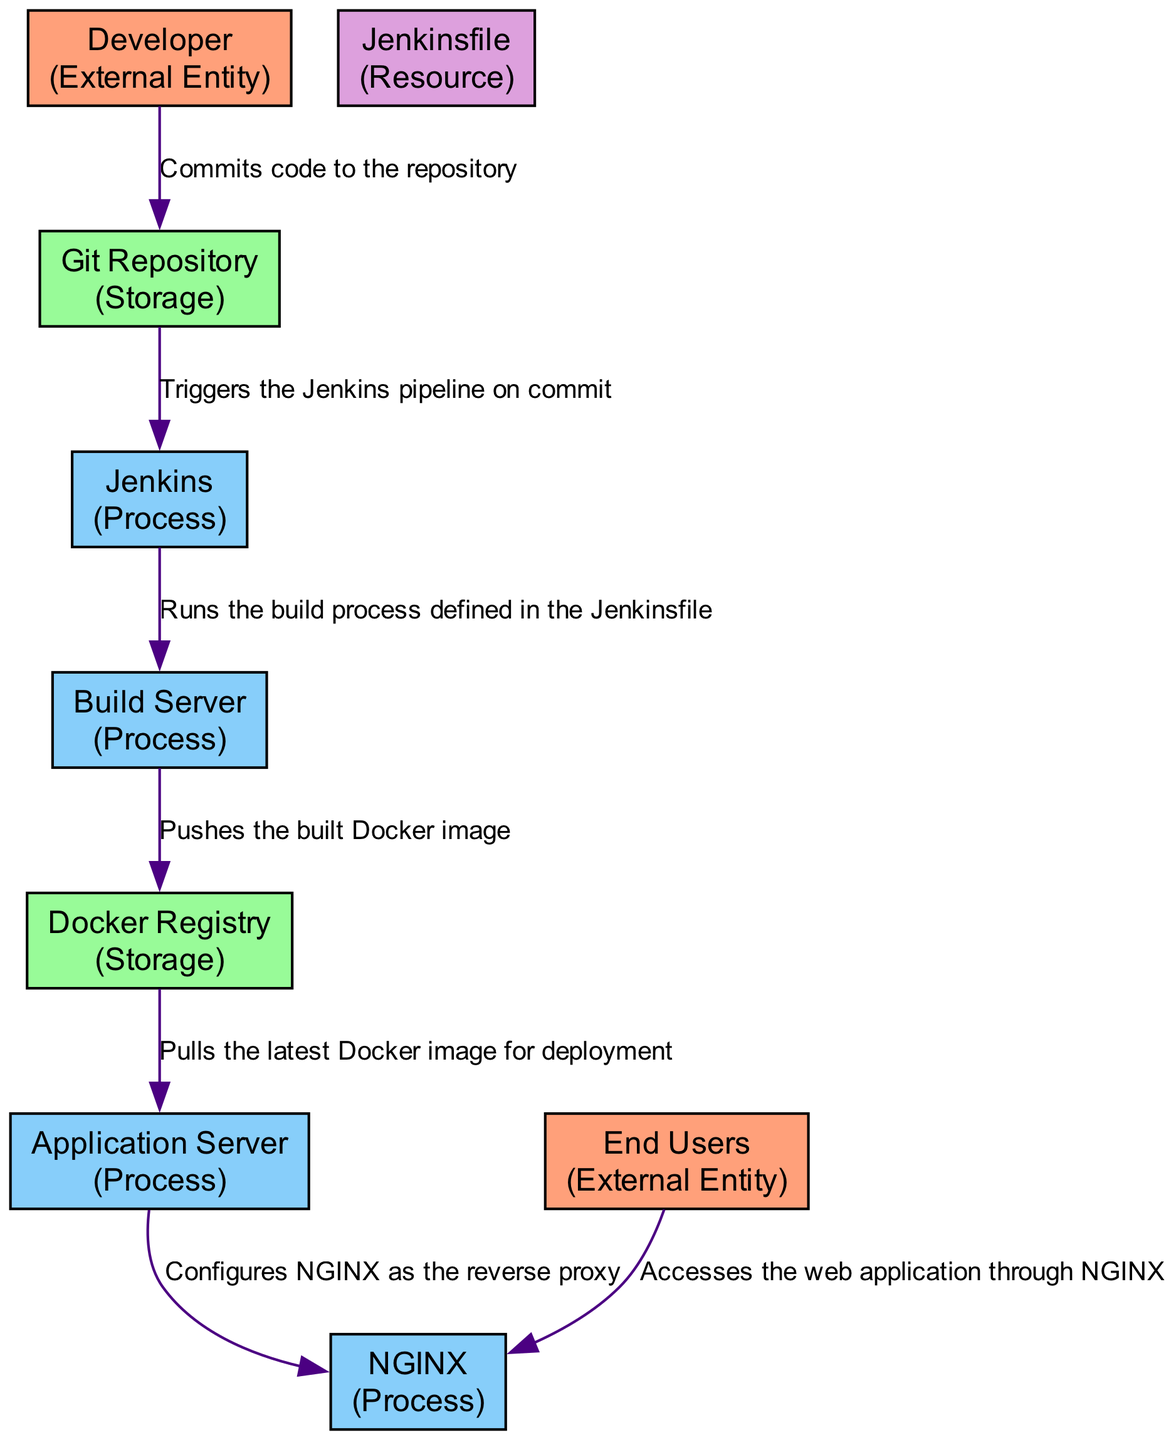What entity initiates the code commit process? The diagram clearly indicates that the "Developer" is the external entity responsible for initiating the code commit process, as labeled in the diagram.
Answer: Developer How many external entities are represented in the diagram? By counting the external entities in the provided entities list, we see that there are two: "Developer" and "End Users." Therefore, the total is two.
Answer: 2 What process automates the deployment pipeline? According to the diagram, "Jenkins" is identified as the continuous integration and continuous deployment server that automates the entire deployment pipeline, which is explicitly stated in its description.
Answer: Jenkins Which entity stores the committed code? The "Git Repository" is designated as the storage entity for the committed code, as noted in its description within the diagram.
Answer: Git Repository What does the Build Server push to the Docker Registry? The flow from "Build Server" to "Docker Registry" specifies that the build server pushes the "built Docker image" to the Docker Registry, which conveys the specific item transferred.
Answer: Built Docker image What is the role of NGINX in this deployment pipeline? The diagram states that "NGINX" acts as a reverse proxy server that directs traffic to the application, as outlined in its description.
Answer: Reverse Proxy What is the first data flow in the diagram? The first data flow is described as the code being committed from the "Developer" to the "Git Repository," indicating the process's initiation point in the diagram flow.
Answer: Commits code to the repository Which entity accesses the web application? The diagram specifies that "End Users" are the ones who access the deployed web application, as indicated in their description.
Answer: End Users How does the Application Server interact with NGINX? The diagram illustrates that the "Application Server" configures NGINX as the reverse proxy, initiating the next step in the data flow toward user access.
Answer: Configures NGINX as the reverse proxy 